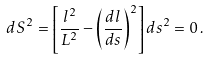<formula> <loc_0><loc_0><loc_500><loc_500>d S ^ { 2 } = \left [ \frac { l ^ { 2 } } { L ^ { 2 } } - \left ( \frac { d l } { d s } \right ) ^ { 2 } \right ] d s ^ { 2 } = 0 \, .</formula> 